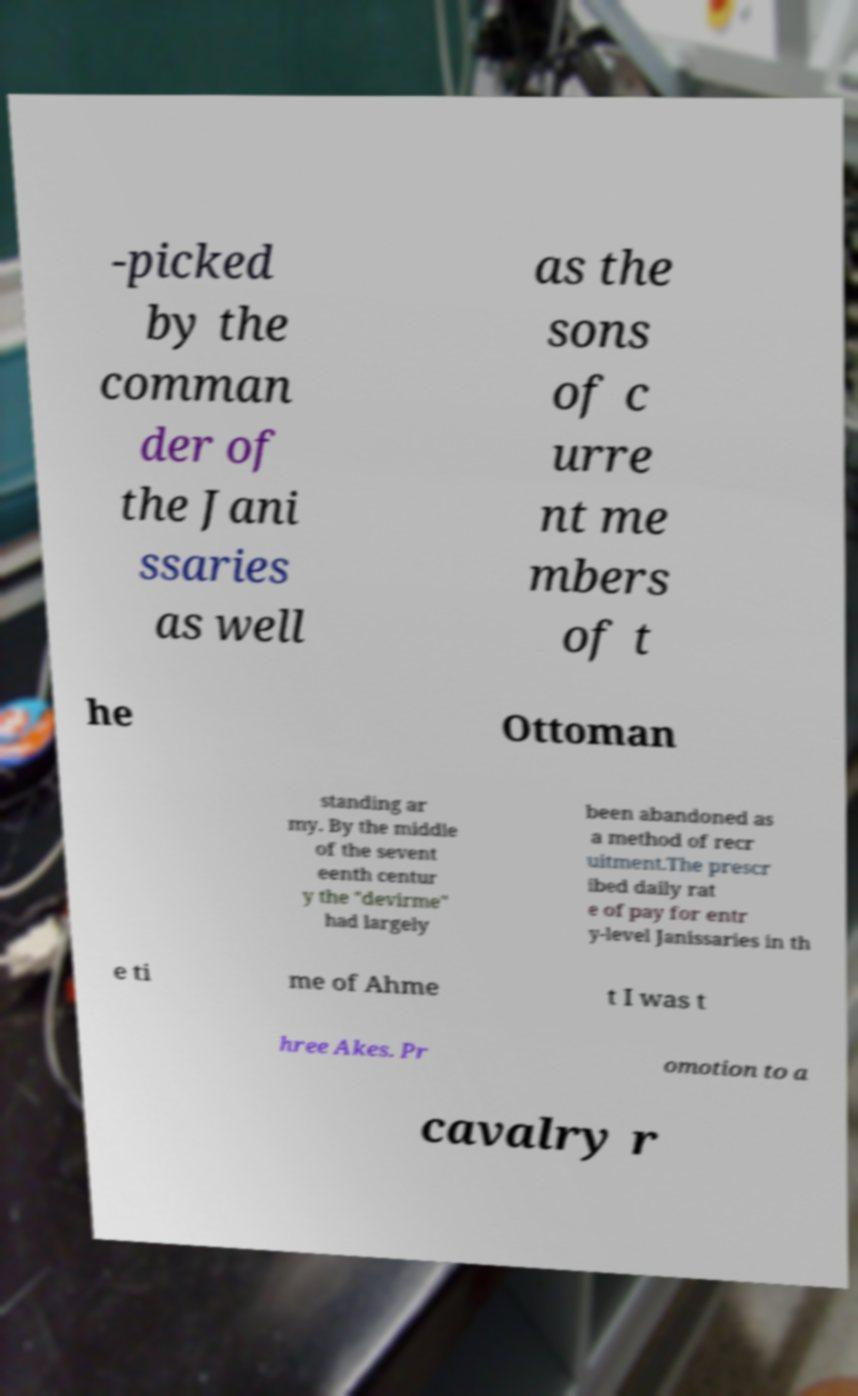Please read and relay the text visible in this image. What does it say? -picked by the comman der of the Jani ssaries as well as the sons of c urre nt me mbers of t he Ottoman standing ar my. By the middle of the sevent eenth centur y the "devirme" had largely been abandoned as a method of recr uitment.The prescr ibed daily rat e of pay for entr y-level Janissaries in th e ti me of Ahme t I was t hree Akes. Pr omotion to a cavalry r 